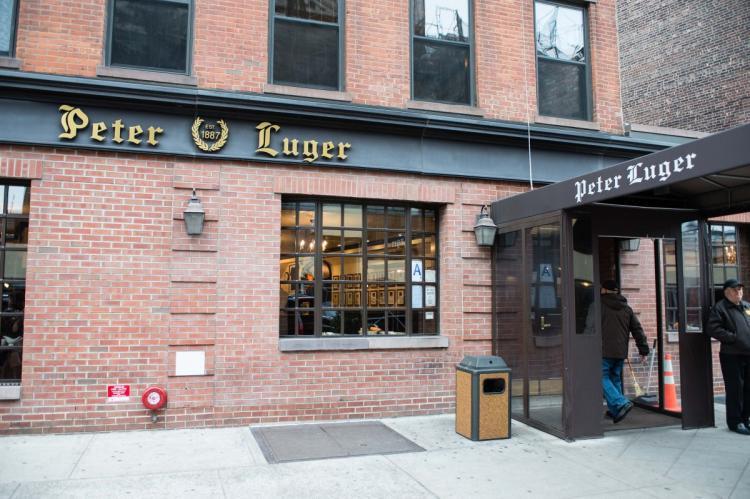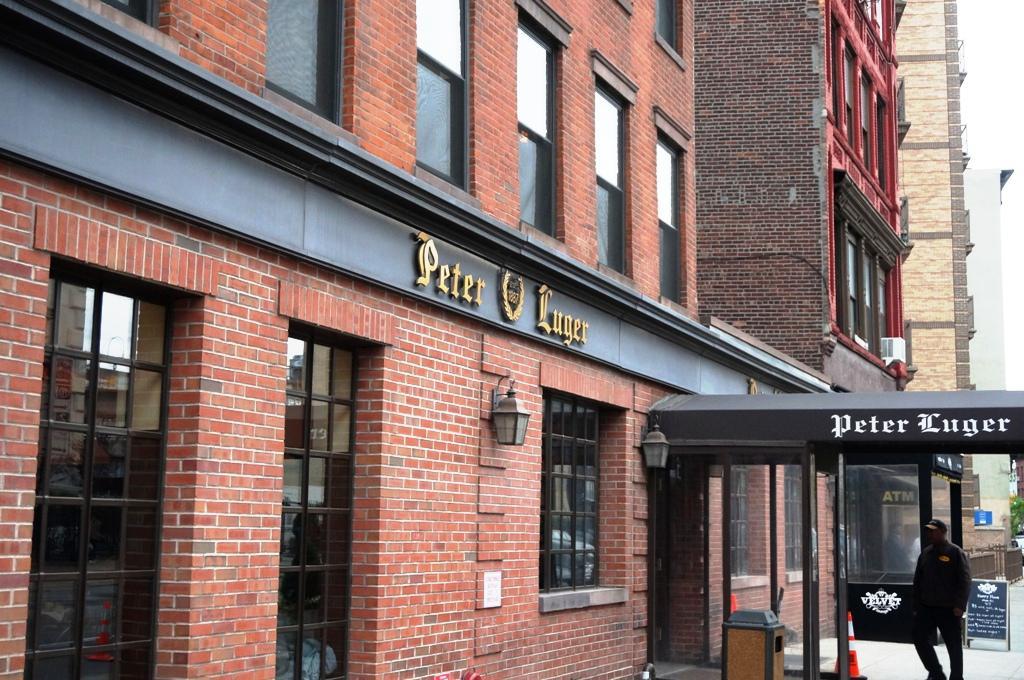The first image is the image on the left, the second image is the image on the right. Given the left and right images, does the statement "The right image shows at least one person in front of a black roof that extends out from a red brick building." hold true? Answer yes or no. Yes. The first image is the image on the left, the second image is the image on the right. Evaluate the accuracy of this statement regarding the images: "There is a front awning in the left image.". Is it true? Answer yes or no. Yes. 